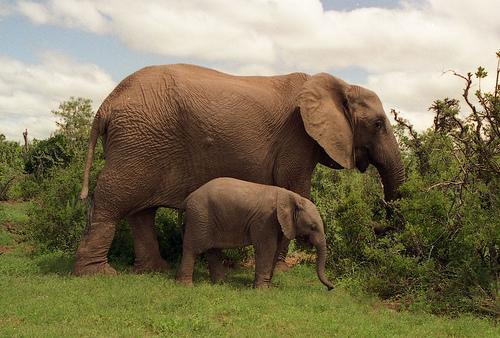How many elephants are there?
Give a very brief answer. 2. 